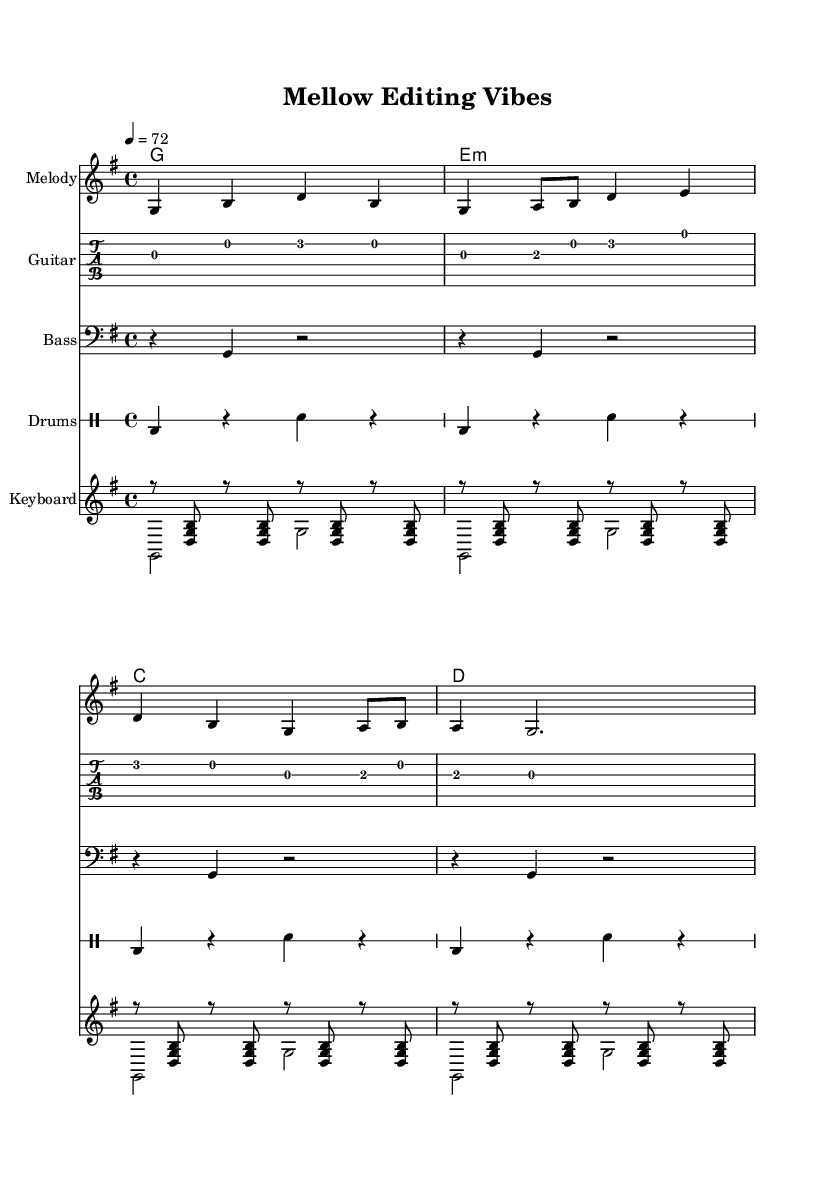What is the key signature of this music? The key signature is G major, which has one sharps (F#).
Answer: G major What is the time signature of this piece? The time signature is 4/4, which indicates there are four beats in each measure.
Answer: 4/4 What is the tempo marking of the music? The tempo marking indicates a speed of 72 beats per minute, suggesting a relaxed pace suitable for mellow reggae.
Answer: 72 How many measures are in the melody section? The melody section has a total of four measures, as indicated by the number of grouped notes across the staff.
Answer: 4 Which chord is played on the first measure? The first chord is a G major chord, indicated by the chord symbol on the first line of the chord names.
Answer: G What rhythmic pattern is used for the drums section? The drum section uses a simple alternating pattern of bass and snare in quarter notes.
Answer: Bass and snare How many different instruments are included in the score? The score includes four different instruments: Melody, Guitar, Bass, and Drums.
Answer: Four 